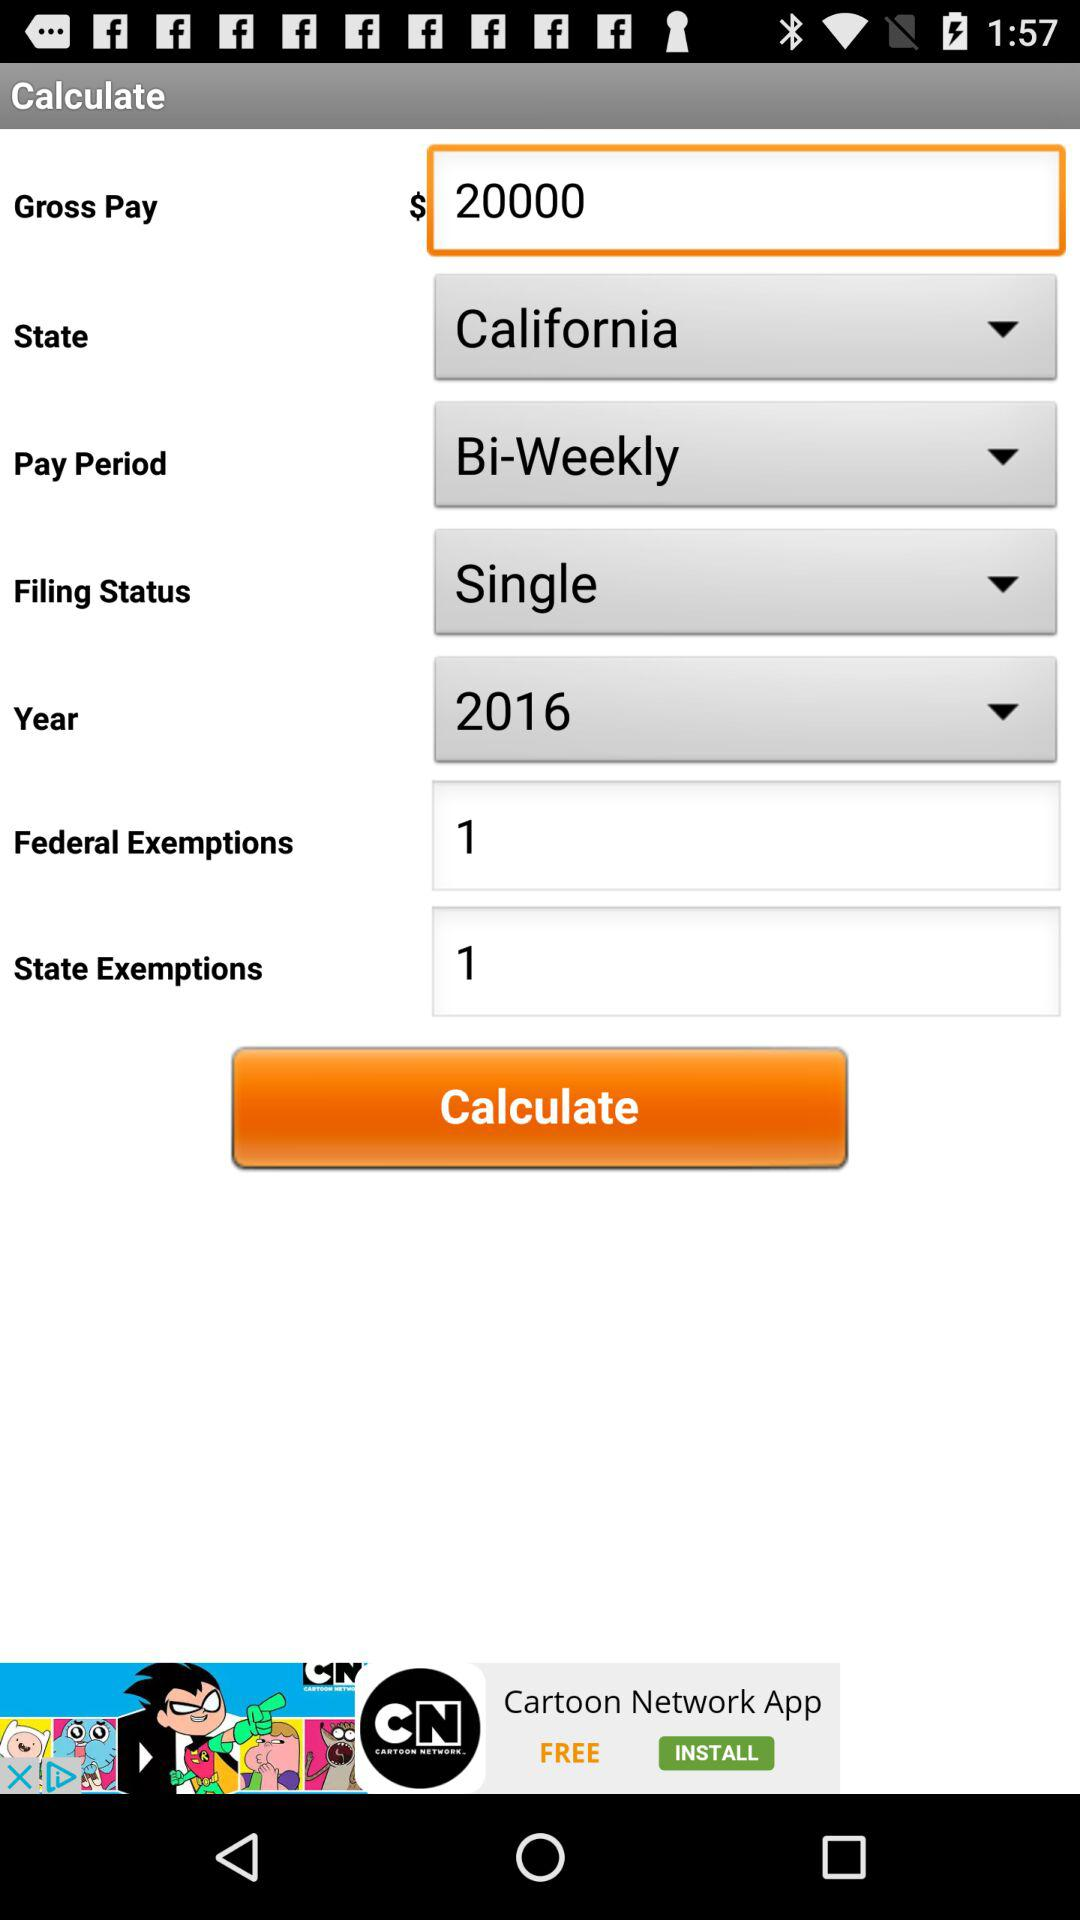What is the "State Exemptions"? The "State Exemptions" is 1. 